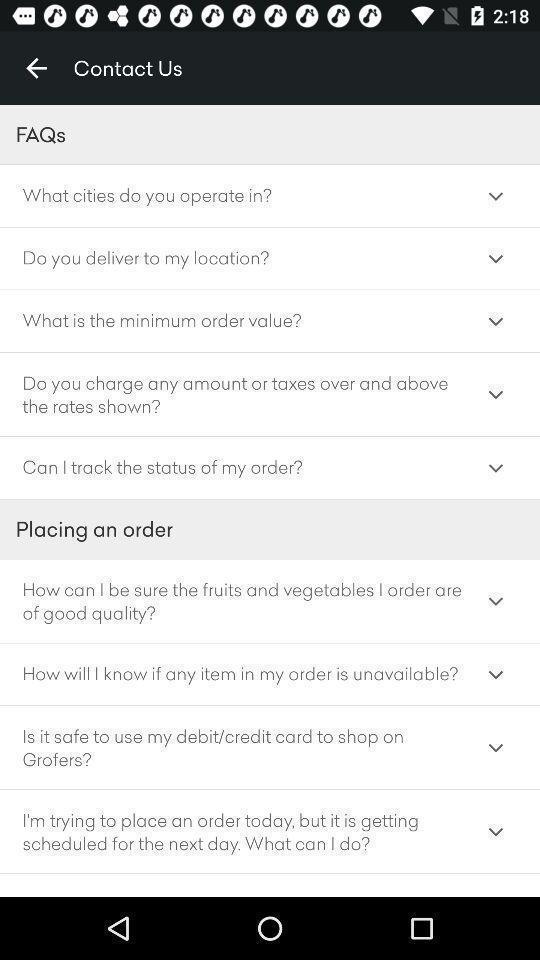Provide a textual representation of this image. Screen displaying frequently asked questions page. 